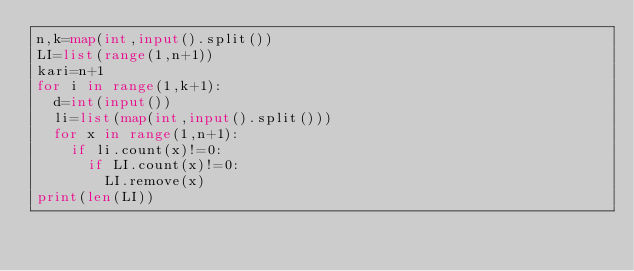<code> <loc_0><loc_0><loc_500><loc_500><_Python_>n,k=map(int,input().split())
LI=list(range(1,n+1))
kari=n+1
for i in range(1,k+1):
  d=int(input())
  li=list(map(int,input().split()))
  for x in range(1,n+1):
    if li.count(x)!=0:
      if LI.count(x)!=0:
        LI.remove(x)
print(len(LI))
      
      
    </code> 